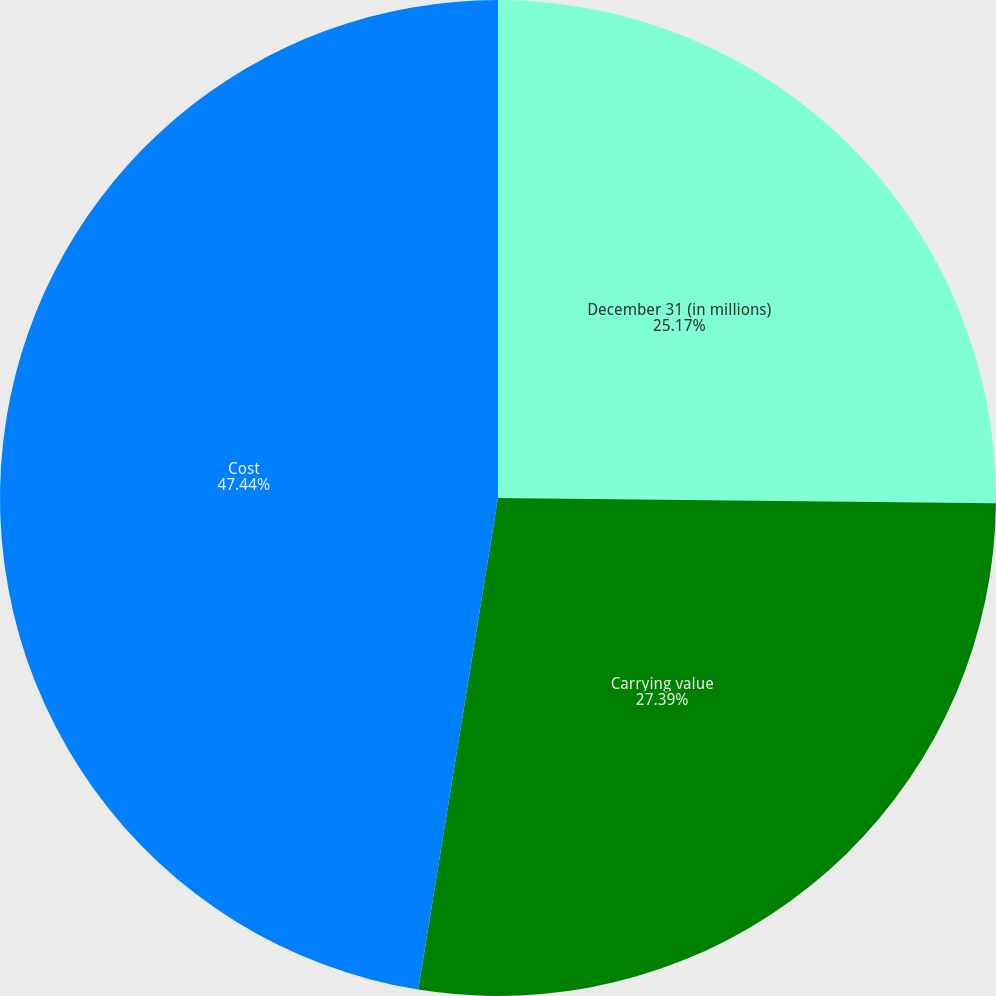Convert chart. <chart><loc_0><loc_0><loc_500><loc_500><pie_chart><fcel>December 31 (in millions)<fcel>Carrying value<fcel>Cost<nl><fcel>25.17%<fcel>27.39%<fcel>47.44%<nl></chart> 